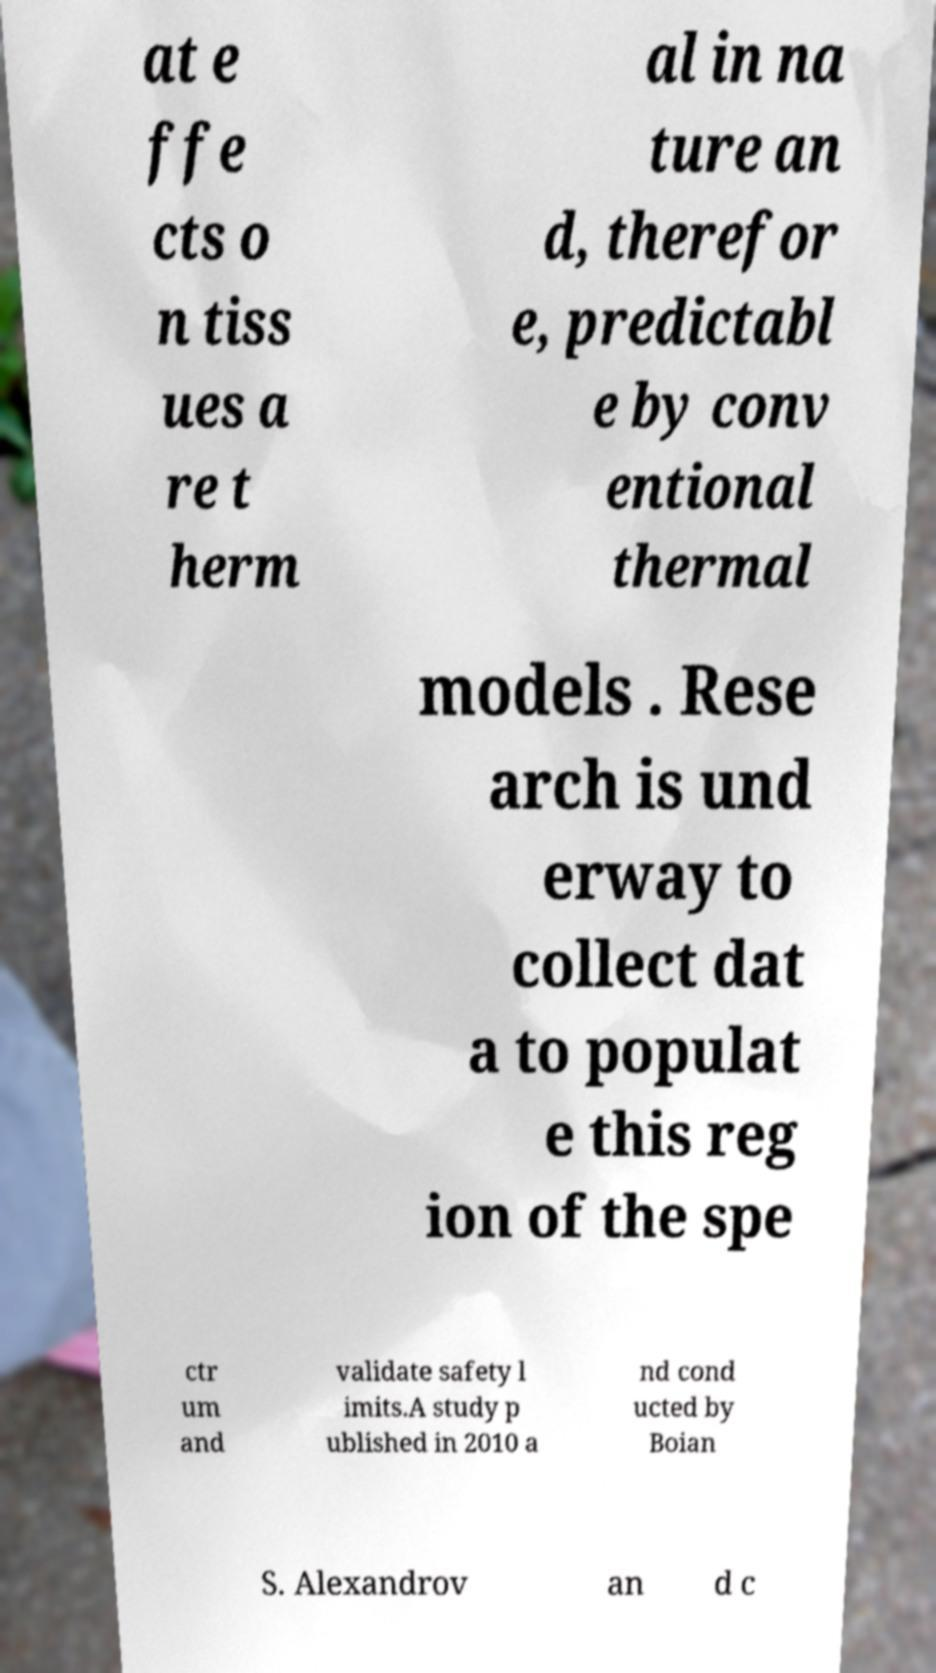Can you accurately transcribe the text from the provided image for me? at e ffe cts o n tiss ues a re t herm al in na ture an d, therefor e, predictabl e by conv entional thermal models . Rese arch is und erway to collect dat a to populat e this reg ion of the spe ctr um and validate safety l imits.A study p ublished in 2010 a nd cond ucted by Boian S. Alexandrov an d c 